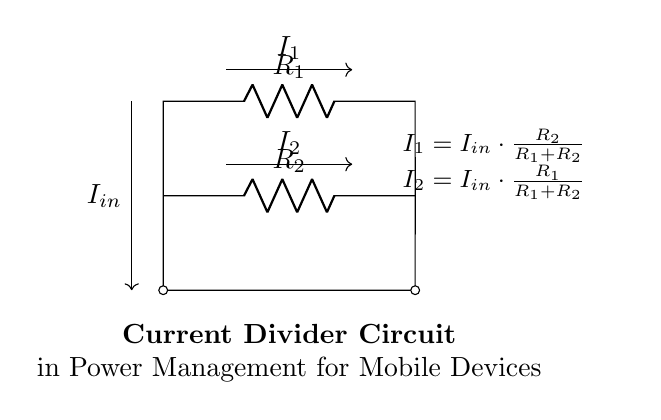What are the resistors in this circuit? The circuit diagram shows two resistors identified as R1 and R2. The labels indicate their placement in the circuit.
Answer: R1, R2 What is the total input current in the circuit? The circuit does not specify a numerical value for the input current (Iin) but denotes it as the incoming current to the resistors.
Answer: Iin How do the resistors affect the output currents? The formula presented below the circuit states that the output currents (I1 and I2) are derived from the input current (Iin) and the values of the resistors R1 and R2, indicating the dependency on their resistance values.
Answer: Proportional to R1 and R2 What is the expression for I1 in this circuit? The circuit provides the formula I1 = Iin * (R2 / (R1 + R2)), indicating how I1 is calculated using the input current and the resistance values.
Answer: Iin * (R2 / (R1 + R2)) What happens to I2 if R1 increases? If R1 increases, the formula for I2 indicates that the proportion of current flowing through I2 will decrease because the ratio R1/(R1 + R2) will be affected, resulting in a lower value for I2.
Answer: I2 decreases Which current is larger for equal resistances? When R1 equals R2, both resistors divide the input current evenly, making I1 equal to I2. Therefore, neither current is larger; they are equal in value.
Answer: They are equal 